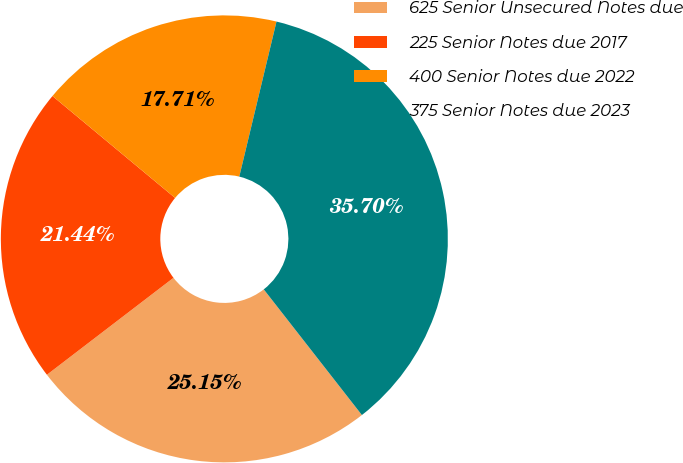<chart> <loc_0><loc_0><loc_500><loc_500><pie_chart><fcel>625 Senior Unsecured Notes due<fcel>225 Senior Notes due 2017<fcel>400 Senior Notes due 2022<fcel>375 Senior Notes due 2023<nl><fcel>25.15%<fcel>21.44%<fcel>17.71%<fcel>35.7%<nl></chart> 